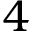Convert formula to latex. <formula><loc_0><loc_0><loc_500><loc_500>4</formula> 